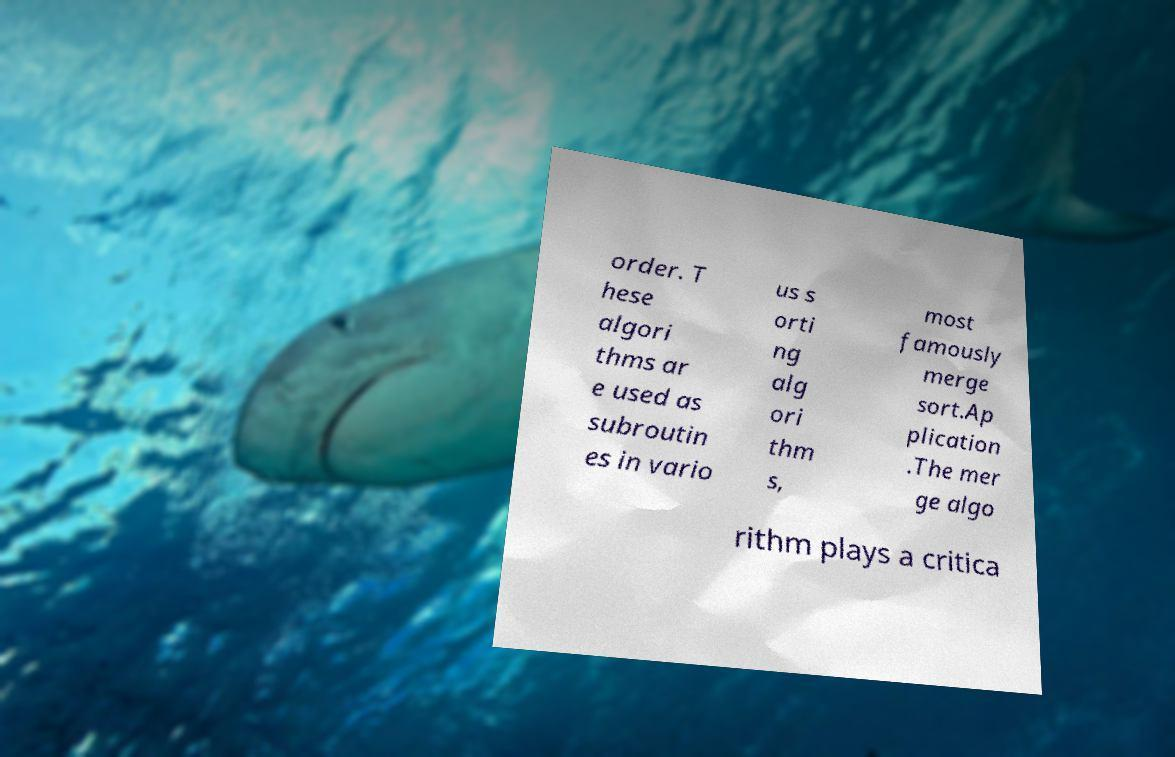Please identify and transcribe the text found in this image. order. T hese algori thms ar e used as subroutin es in vario us s orti ng alg ori thm s, most famously merge sort.Ap plication .The mer ge algo rithm plays a critica 